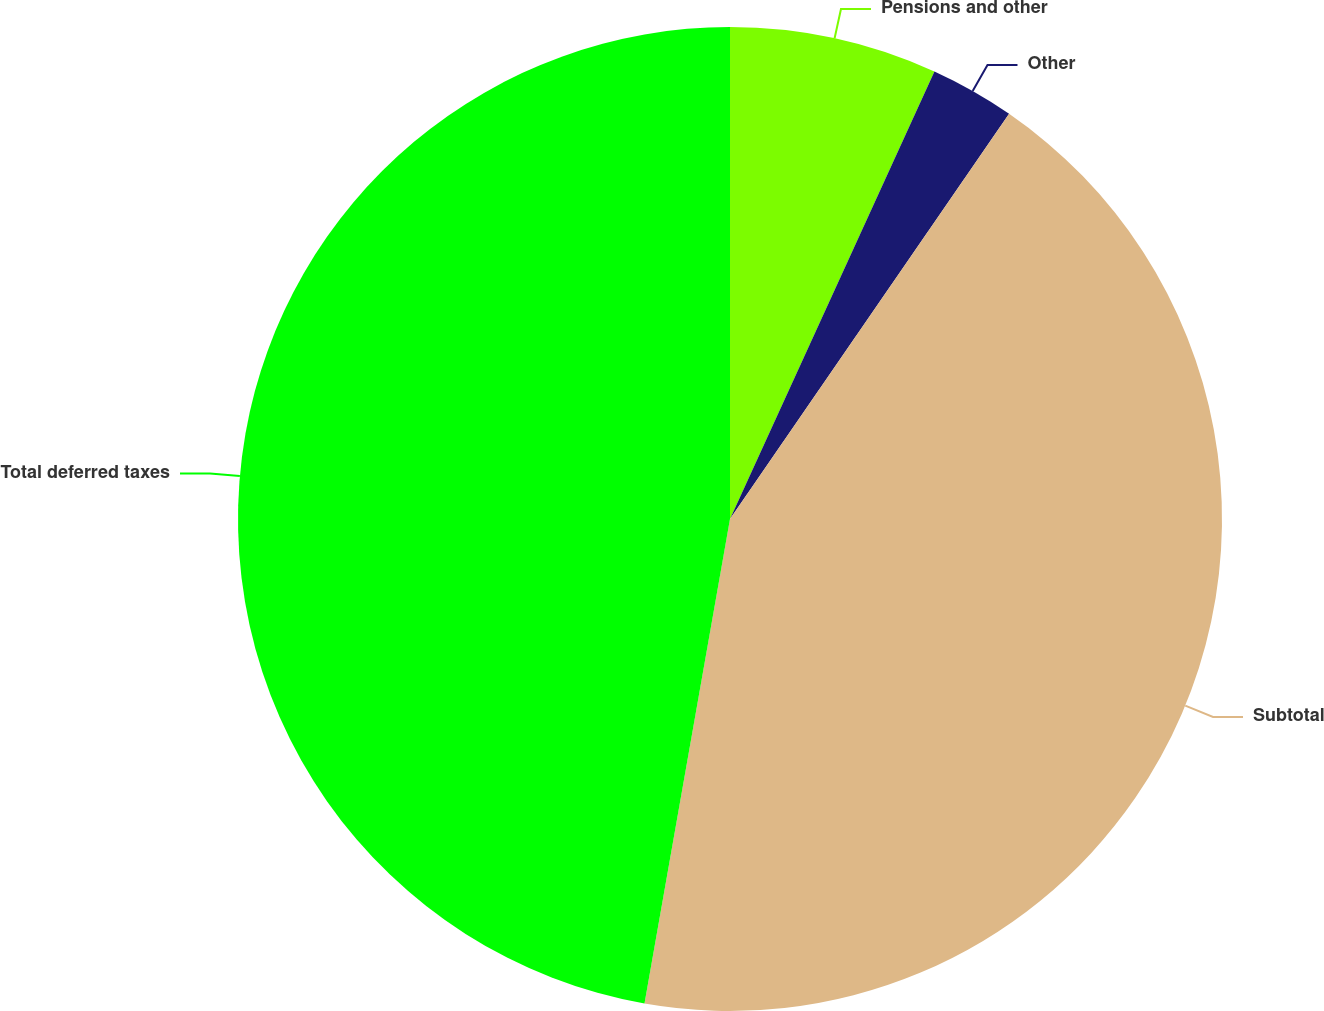<chart> <loc_0><loc_0><loc_500><loc_500><pie_chart><fcel>Pensions and other<fcel>Other<fcel>Subtotal<fcel>Total deferred taxes<nl><fcel>6.82%<fcel>2.78%<fcel>43.18%<fcel>47.22%<nl></chart> 